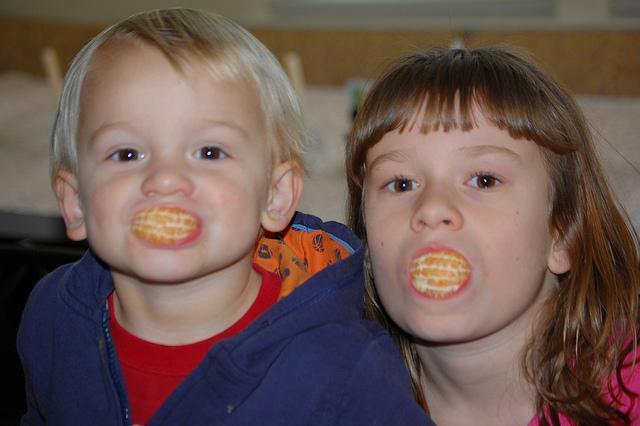How many oranges can be seen?
Give a very brief answer. 2. How many people are there?
Give a very brief answer. 2. 